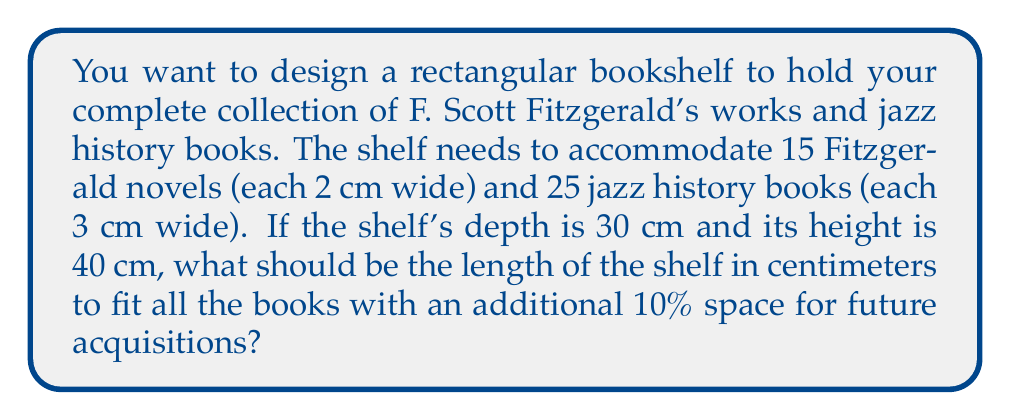Give your solution to this math problem. Let's approach this step-by-step:

1. Calculate the total width of Fitzgerald's novels:
   $15 \text{ books} \times 2 \text{ cm} = 30 \text{ cm}$

2. Calculate the total width of jazz history books:
   $25 \text{ books} \times 3 \text{ cm} = 75 \text{ cm}$

3. Sum up the total width of all books:
   $30 \text{ cm} + 75 \text{ cm} = 105 \text{ cm}$

4. Add 10% extra space for future acquisitions:
   $105 \text{ cm} \times 1.1 = 115.5 \text{ cm}$

5. Round up to the nearest centimeter for practicality:
   $115.5 \text{ cm} \approx 116 \text{ cm}$

Therefore, the length of the shelf should be 116 cm to accommodate all books with an additional 10% space.

The shelf's dimensions can be expressed as:
$$\text{Length} \times \text{Depth} \times \text{Height} = 116 \text{ cm} \times 30 \text{ cm} \times 40 \text{ cm}$$

[asy]
unitsize(0.05cm);
draw((0,0)--(116,0)--(116,40)--(0,40)--cycle);
draw((0,0)--(30,30)--(146,30)--(116,0));
draw((116,40)--(146,30));
label("116 cm", (58,-5));
label("40 cm", (121,20));
label("30 cm", (138,15));
[/asy]
Answer: $116 \text{ cm} \times 30 \text{ cm} \times 40 \text{ cm}$ 